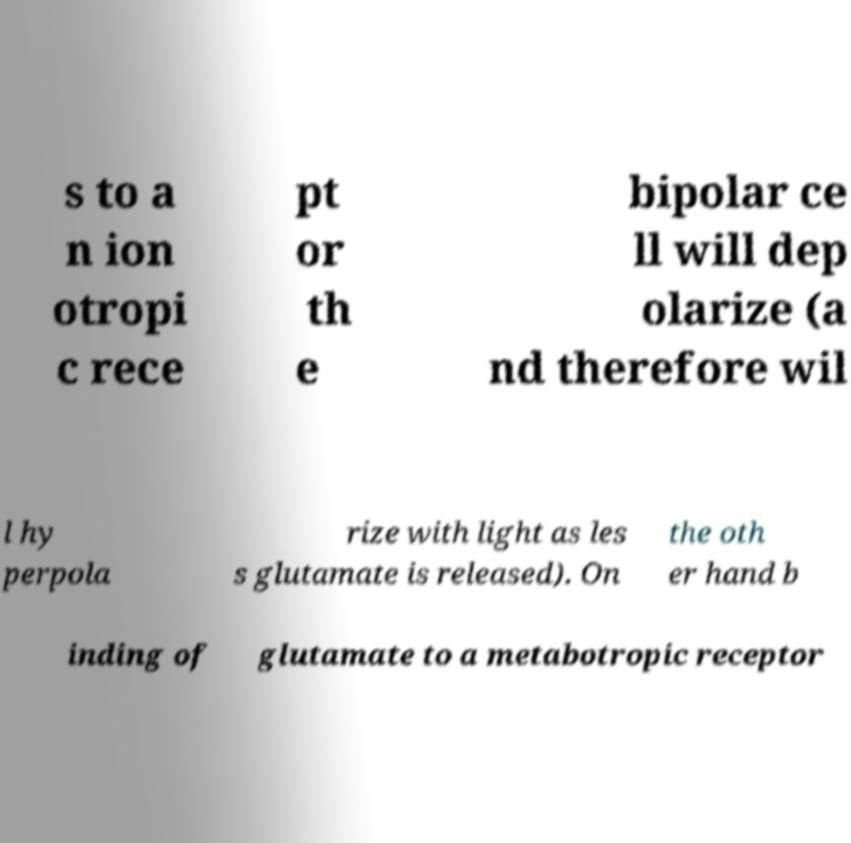There's text embedded in this image that I need extracted. Can you transcribe it verbatim? s to a n ion otropi c rece pt or th e bipolar ce ll will dep olarize (a nd therefore wil l hy perpola rize with light as les s glutamate is released). On the oth er hand b inding of glutamate to a metabotropic receptor 